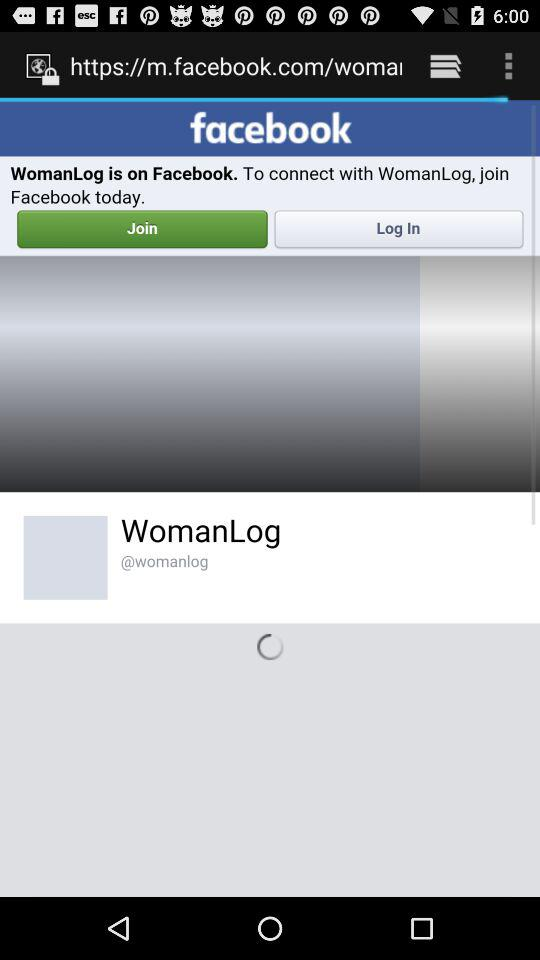What is the name of the page?
When the provided information is insufficient, respond with <no answer>. <no answer> 